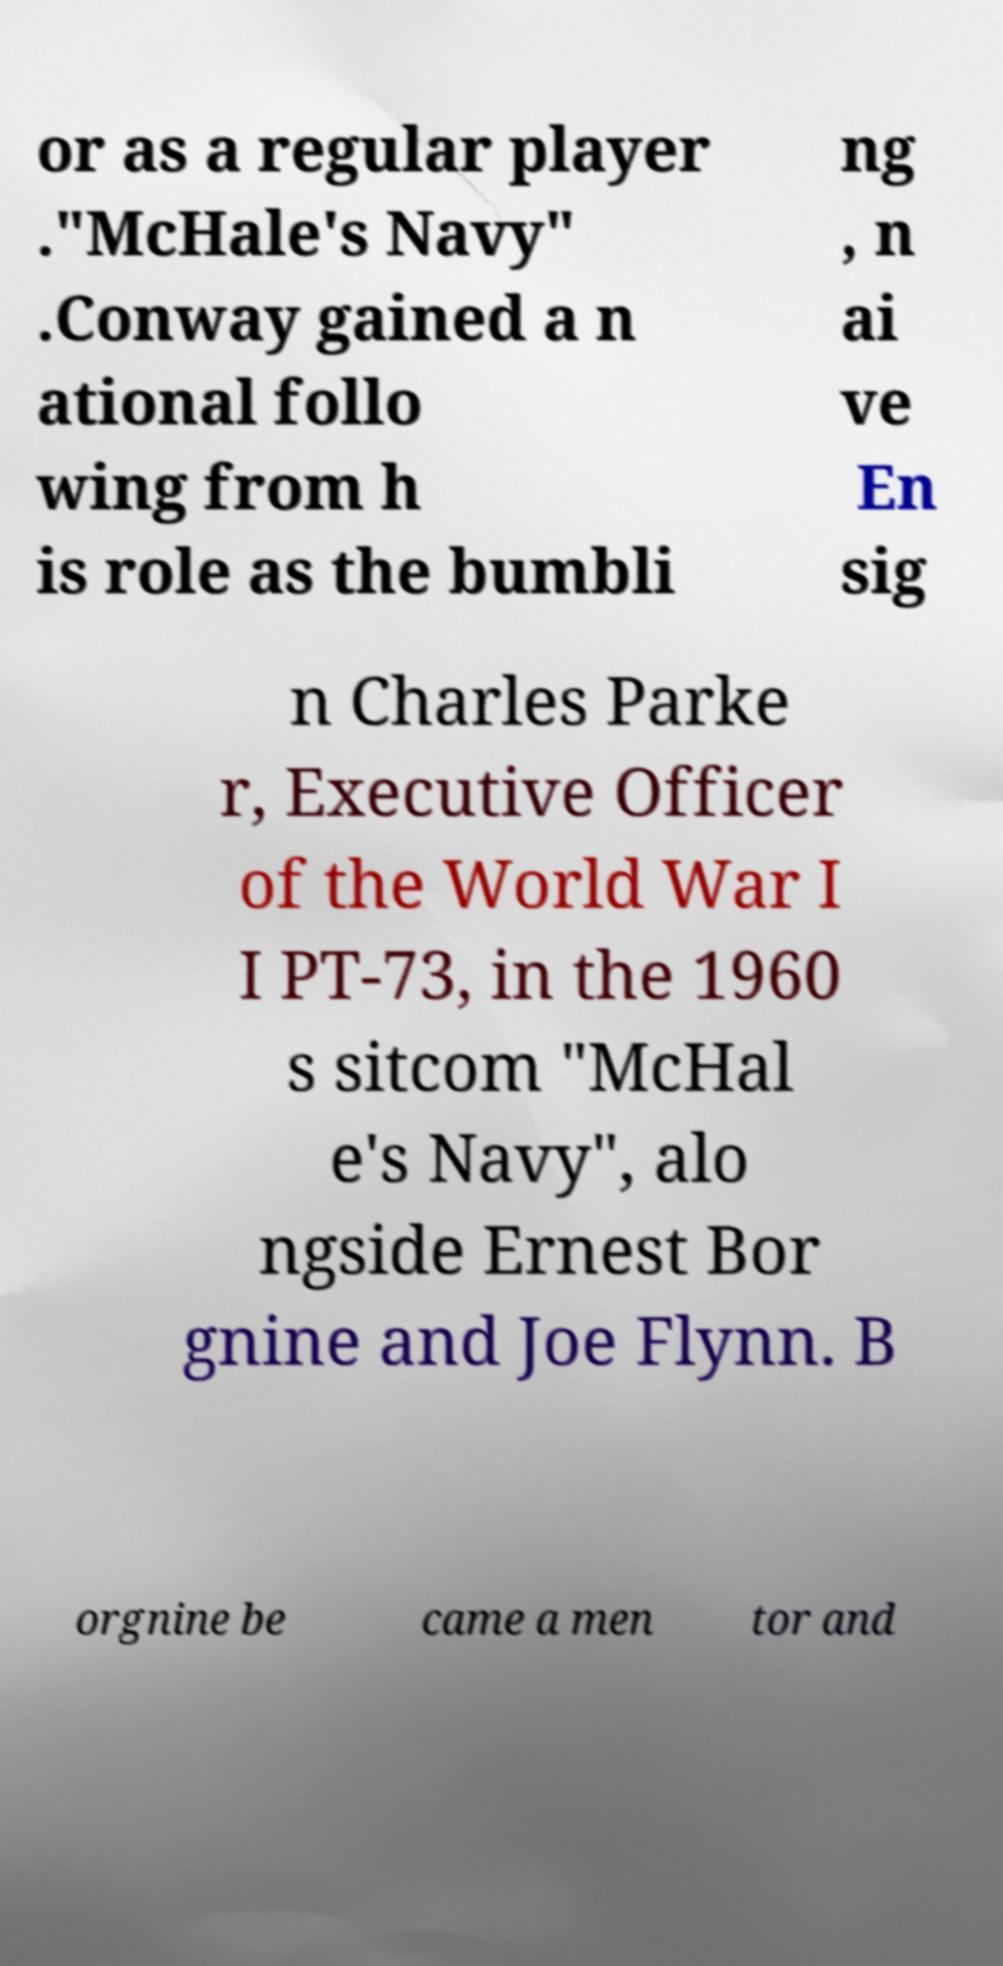For documentation purposes, I need the text within this image transcribed. Could you provide that? or as a regular player ."McHale's Navy" .Conway gained a n ational follo wing from h is role as the bumbli ng , n ai ve En sig n Charles Parke r, Executive Officer of the World War I I PT-73, in the 1960 s sitcom "McHal e's Navy", alo ngside Ernest Bor gnine and Joe Flynn. B orgnine be came a men tor and 